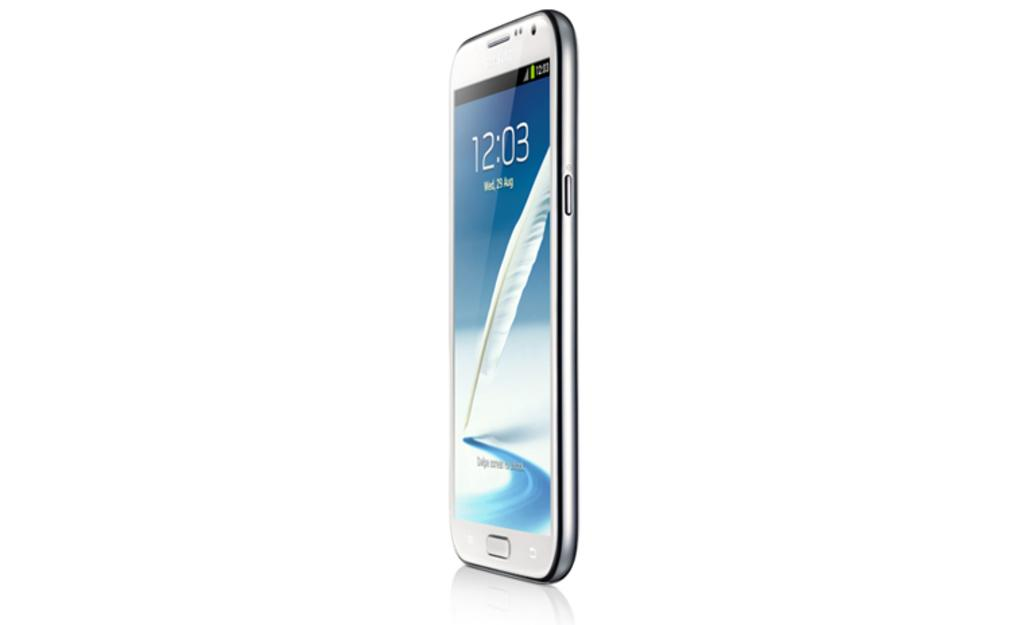Provide a one-sentence caption for the provided image. Wed August the 9th is written on the face of a silver cell phone. 